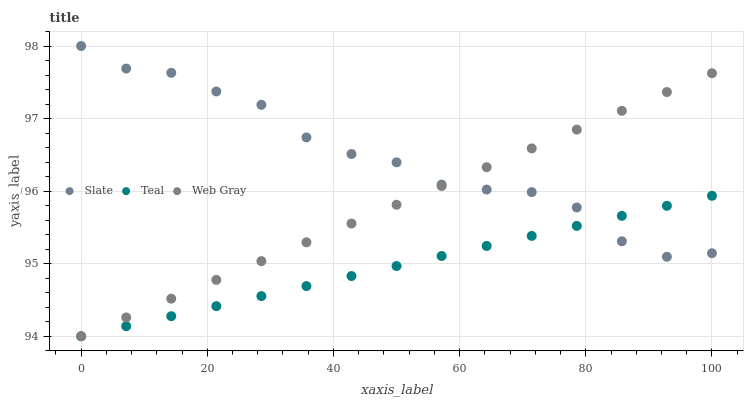Does Teal have the minimum area under the curve?
Answer yes or no. Yes. Does Slate have the maximum area under the curve?
Answer yes or no. Yes. Does Web Gray have the minimum area under the curve?
Answer yes or no. No. Does Web Gray have the maximum area under the curve?
Answer yes or no. No. Is Web Gray the smoothest?
Answer yes or no. Yes. Is Slate the roughest?
Answer yes or no. Yes. Is Teal the smoothest?
Answer yes or no. No. Is Teal the roughest?
Answer yes or no. No. Does Web Gray have the lowest value?
Answer yes or no. Yes. Does Slate have the highest value?
Answer yes or no. Yes. Does Web Gray have the highest value?
Answer yes or no. No. Does Slate intersect Web Gray?
Answer yes or no. Yes. Is Slate less than Web Gray?
Answer yes or no. No. Is Slate greater than Web Gray?
Answer yes or no. No. 